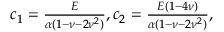Convert formula to latex. <formula><loc_0><loc_0><loc_500><loc_500>\begin{array} { r } { c _ { 1 } = \frac { E } { \alpha ( 1 - \nu - 2 \nu ^ { 2 } ) } , c _ { 2 } = \frac { E ( 1 - 4 \nu ) } { \alpha ( 1 - \nu - 2 \nu ^ { 2 } ) } , } \end{array}</formula> 